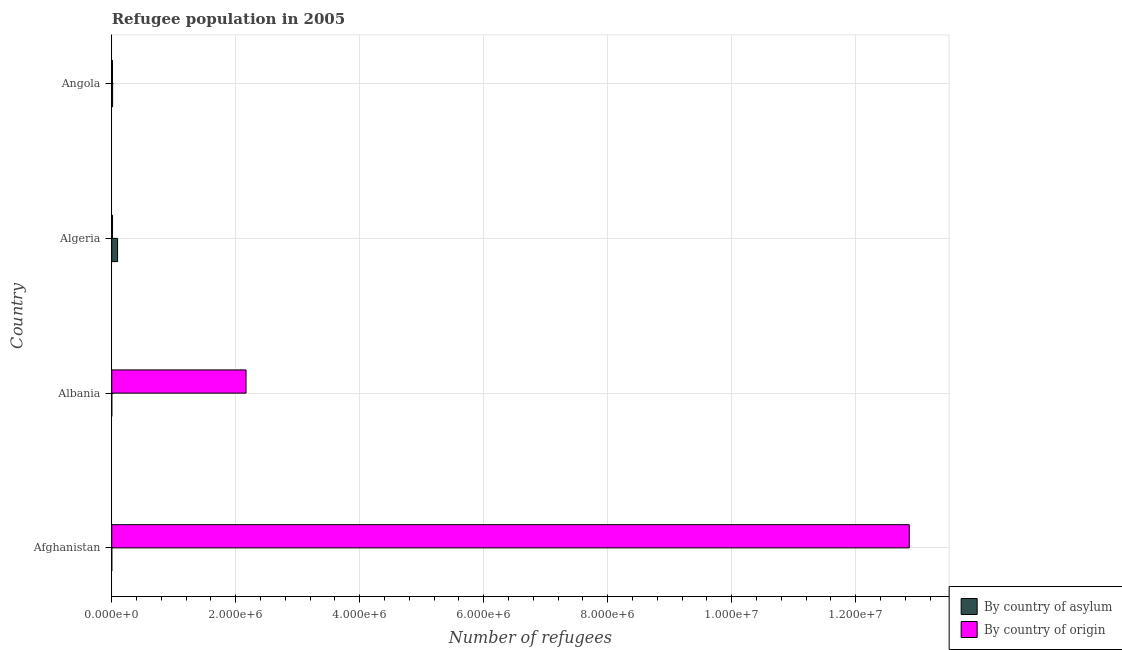How many different coloured bars are there?
Offer a terse response. 2. How many groups of bars are there?
Your answer should be compact. 4. Are the number of bars per tick equal to the number of legend labels?
Your answer should be compact. Yes. How many bars are there on the 3rd tick from the top?
Offer a terse response. 2. What is the label of the 1st group of bars from the top?
Offer a terse response. Angola. What is the number of refugees by country of origin in Albania?
Your answer should be compact. 2.17e+06. Across all countries, what is the maximum number of refugees by country of origin?
Keep it short and to the point. 1.29e+07. Across all countries, what is the minimum number of refugees by country of asylum?
Your response must be concise. 32. In which country was the number of refugees by country of asylum maximum?
Offer a terse response. Algeria. In which country was the number of refugees by country of origin minimum?
Provide a short and direct response. Angola. What is the total number of refugees by country of origin in the graph?
Offer a terse response. 1.51e+07. What is the difference between the number of refugees by country of asylum in Afghanistan and that in Algeria?
Provide a succinct answer. -9.41e+04. What is the difference between the number of refugees by country of origin in Angola and the number of refugees by country of asylum in Algeria?
Give a very brief answer. -8.21e+04. What is the average number of refugees by country of asylum per country?
Offer a very short reply. 2.70e+04. What is the difference between the number of refugees by country of origin and number of refugees by country of asylum in Angola?
Your answer should be compact. -1943. In how many countries, is the number of refugees by country of origin greater than 7200000 ?
Provide a short and direct response. 1. What is the ratio of the number of refugees by country of origin in Afghanistan to that in Angola?
Your response must be concise. 1068.32. Is the number of refugees by country of origin in Algeria less than that in Angola?
Ensure brevity in your answer.  No. What is the difference between the highest and the second highest number of refugees by country of asylum?
Your answer should be compact. 8.01e+04. What is the difference between the highest and the lowest number of refugees by country of asylum?
Your answer should be very brief. 9.41e+04. What does the 2nd bar from the top in Albania represents?
Keep it short and to the point. By country of asylum. What does the 2nd bar from the bottom in Algeria represents?
Provide a succinct answer. By country of origin. Are all the bars in the graph horizontal?
Provide a short and direct response. Yes. Does the graph contain any zero values?
Offer a very short reply. No. Does the graph contain grids?
Give a very brief answer. Yes. How many legend labels are there?
Provide a succinct answer. 2. How are the legend labels stacked?
Offer a terse response. Vertical. What is the title of the graph?
Your answer should be compact. Refugee population in 2005. What is the label or title of the X-axis?
Your answer should be compact. Number of refugees. What is the label or title of the Y-axis?
Provide a short and direct response. Country. What is the Number of refugees of By country of origin in Afghanistan?
Offer a very short reply. 1.29e+07. What is the Number of refugees in By country of origin in Albania?
Make the answer very short. 2.17e+06. What is the Number of refugees of By country of asylum in Algeria?
Make the answer very short. 9.41e+04. What is the Number of refugees in By country of origin in Algeria?
Make the answer very short. 1.27e+04. What is the Number of refugees in By country of asylum in Angola?
Keep it short and to the point. 1.40e+04. What is the Number of refugees of By country of origin in Angola?
Offer a terse response. 1.20e+04. Across all countries, what is the maximum Number of refugees in By country of asylum?
Your answer should be very brief. 9.41e+04. Across all countries, what is the maximum Number of refugees of By country of origin?
Provide a succinct answer. 1.29e+07. Across all countries, what is the minimum Number of refugees in By country of origin?
Keep it short and to the point. 1.20e+04. What is the total Number of refugees of By country of asylum in the graph?
Provide a succinct answer. 1.08e+05. What is the total Number of refugees in By country of origin in the graph?
Keep it short and to the point. 1.51e+07. What is the difference between the Number of refugees of By country of origin in Afghanistan and that in Albania?
Your response must be concise. 1.07e+07. What is the difference between the Number of refugees in By country of asylum in Afghanistan and that in Algeria?
Your answer should be compact. -9.41e+04. What is the difference between the Number of refugees of By country of origin in Afghanistan and that in Algeria?
Provide a short and direct response. 1.29e+07. What is the difference between the Number of refugees of By country of asylum in Afghanistan and that in Angola?
Provide a succinct answer. -1.40e+04. What is the difference between the Number of refugees of By country of origin in Afghanistan and that in Angola?
Give a very brief answer. 1.29e+07. What is the difference between the Number of refugees of By country of asylum in Albania and that in Algeria?
Your answer should be compact. -9.40e+04. What is the difference between the Number of refugees in By country of origin in Albania and that in Algeria?
Ensure brevity in your answer.  2.15e+06. What is the difference between the Number of refugees of By country of asylum in Albania and that in Angola?
Provide a short and direct response. -1.39e+04. What is the difference between the Number of refugees in By country of origin in Albania and that in Angola?
Provide a succinct answer. 2.15e+06. What is the difference between the Number of refugees of By country of asylum in Algeria and that in Angola?
Provide a short and direct response. 8.01e+04. What is the difference between the Number of refugees of By country of origin in Algeria and that in Angola?
Your answer should be compact. 681. What is the difference between the Number of refugees of By country of asylum in Afghanistan and the Number of refugees of By country of origin in Albania?
Your answer should be compact. -2.17e+06. What is the difference between the Number of refugees of By country of asylum in Afghanistan and the Number of refugees of By country of origin in Algeria?
Ensure brevity in your answer.  -1.27e+04. What is the difference between the Number of refugees of By country of asylum in Afghanistan and the Number of refugees of By country of origin in Angola?
Offer a very short reply. -1.20e+04. What is the difference between the Number of refugees in By country of asylum in Albania and the Number of refugees in By country of origin in Algeria?
Your answer should be compact. -1.27e+04. What is the difference between the Number of refugees of By country of asylum in Albania and the Number of refugees of By country of origin in Angola?
Provide a succinct answer. -1.20e+04. What is the difference between the Number of refugees of By country of asylum in Algeria and the Number of refugees of By country of origin in Angola?
Provide a succinct answer. 8.21e+04. What is the average Number of refugees in By country of asylum per country?
Provide a short and direct response. 2.70e+04. What is the average Number of refugees of By country of origin per country?
Offer a very short reply. 3.76e+06. What is the difference between the Number of refugees of By country of asylum and Number of refugees of By country of origin in Afghanistan?
Your response must be concise. -1.29e+07. What is the difference between the Number of refugees of By country of asylum and Number of refugees of By country of origin in Albania?
Ensure brevity in your answer.  -2.17e+06. What is the difference between the Number of refugees of By country of asylum and Number of refugees of By country of origin in Algeria?
Offer a very short reply. 8.14e+04. What is the difference between the Number of refugees of By country of asylum and Number of refugees of By country of origin in Angola?
Your answer should be compact. 1943. What is the ratio of the Number of refugees of By country of asylum in Afghanistan to that in Albania?
Your response must be concise. 0.57. What is the ratio of the Number of refugees in By country of origin in Afghanistan to that in Albania?
Offer a very short reply. 5.94. What is the ratio of the Number of refugees in By country of asylum in Afghanistan to that in Algeria?
Your response must be concise. 0. What is the ratio of the Number of refugees in By country of origin in Afghanistan to that in Algeria?
Keep it short and to the point. 1011.14. What is the ratio of the Number of refugees of By country of asylum in Afghanistan to that in Angola?
Offer a very short reply. 0. What is the ratio of the Number of refugees in By country of origin in Afghanistan to that in Angola?
Give a very brief answer. 1068.32. What is the ratio of the Number of refugees in By country of asylum in Albania to that in Algeria?
Give a very brief answer. 0. What is the ratio of the Number of refugees in By country of origin in Albania to that in Algeria?
Provide a short and direct response. 170.27. What is the ratio of the Number of refugees in By country of asylum in Albania to that in Angola?
Give a very brief answer. 0. What is the ratio of the Number of refugees in By country of origin in Albania to that in Angola?
Provide a short and direct response. 179.9. What is the ratio of the Number of refugees in By country of asylum in Algeria to that in Angola?
Your answer should be very brief. 6.73. What is the ratio of the Number of refugees of By country of origin in Algeria to that in Angola?
Give a very brief answer. 1.06. What is the difference between the highest and the second highest Number of refugees of By country of asylum?
Ensure brevity in your answer.  8.01e+04. What is the difference between the highest and the second highest Number of refugees in By country of origin?
Make the answer very short. 1.07e+07. What is the difference between the highest and the lowest Number of refugees in By country of asylum?
Your answer should be very brief. 9.41e+04. What is the difference between the highest and the lowest Number of refugees in By country of origin?
Offer a terse response. 1.29e+07. 